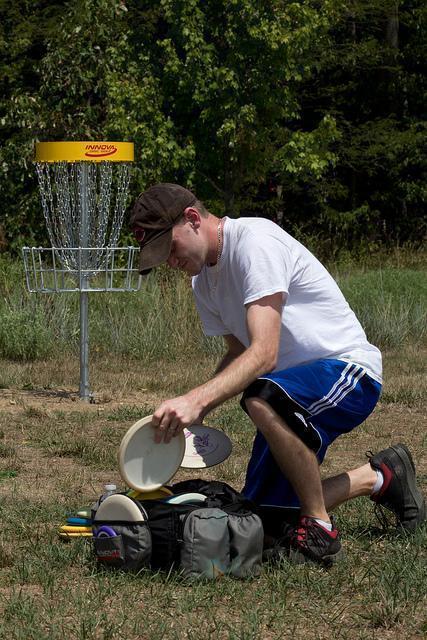The man has what on his head?
Select the accurate response from the four choices given to answer the question.
Options: Umbrella, bonnet, helmet, cap. Cap. 